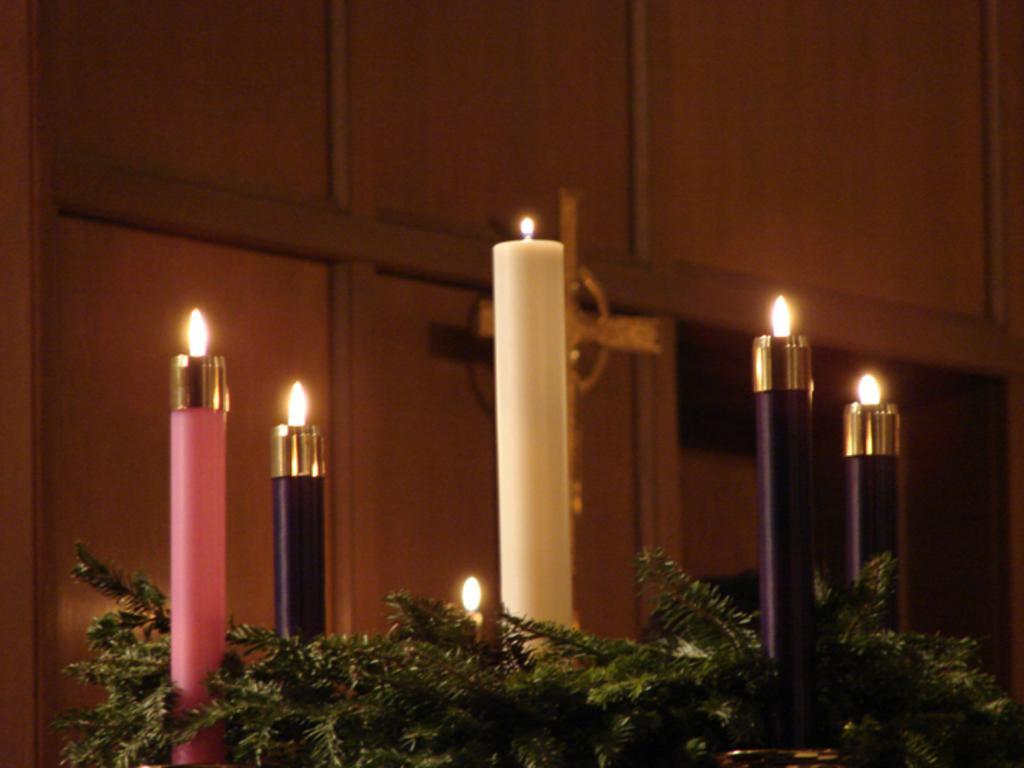Can you describe this image briefly? This picture is taken inside the room. In this image, in the middle, we can see some plants with green leaves and a few candles. In the background, we can see a cross which is attached to a wall. 